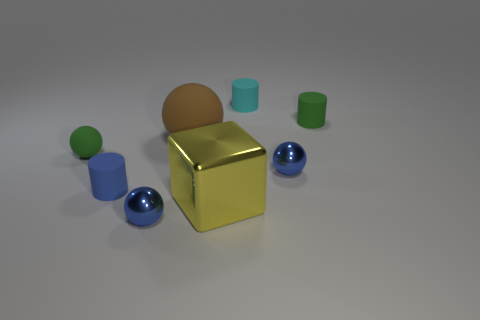Are there any other things that are the same shape as the large yellow thing?
Ensure brevity in your answer.  No. What color is the other tiny matte thing that is the same shape as the brown rubber object?
Your answer should be compact. Green. There is a thing that is both behind the small green matte ball and right of the cyan matte thing; what shape is it?
Provide a succinct answer. Cylinder. How big is the yellow object that is to the left of the tiny cyan rubber object?
Make the answer very short. Large. There is a green matte object that is on the left side of the blue metal object in front of the large metallic block; how many tiny rubber balls are on the left side of it?
Your answer should be very brief. 0. Are there any rubber cylinders to the right of the blue matte thing?
Keep it short and to the point. Yes. How many other things are the same size as the cyan cylinder?
Provide a succinct answer. 5. What is the material of the object that is in front of the green cylinder and on the right side of the yellow metal thing?
Make the answer very short. Metal. There is a blue metallic object that is right of the yellow block; is it the same shape as the tiny green object on the right side of the yellow metal cube?
Your answer should be very brief. No. There is a green thing that is behind the green thing that is left of the rubber cylinder that is left of the cyan rubber cylinder; what is its shape?
Offer a terse response. Cylinder. 